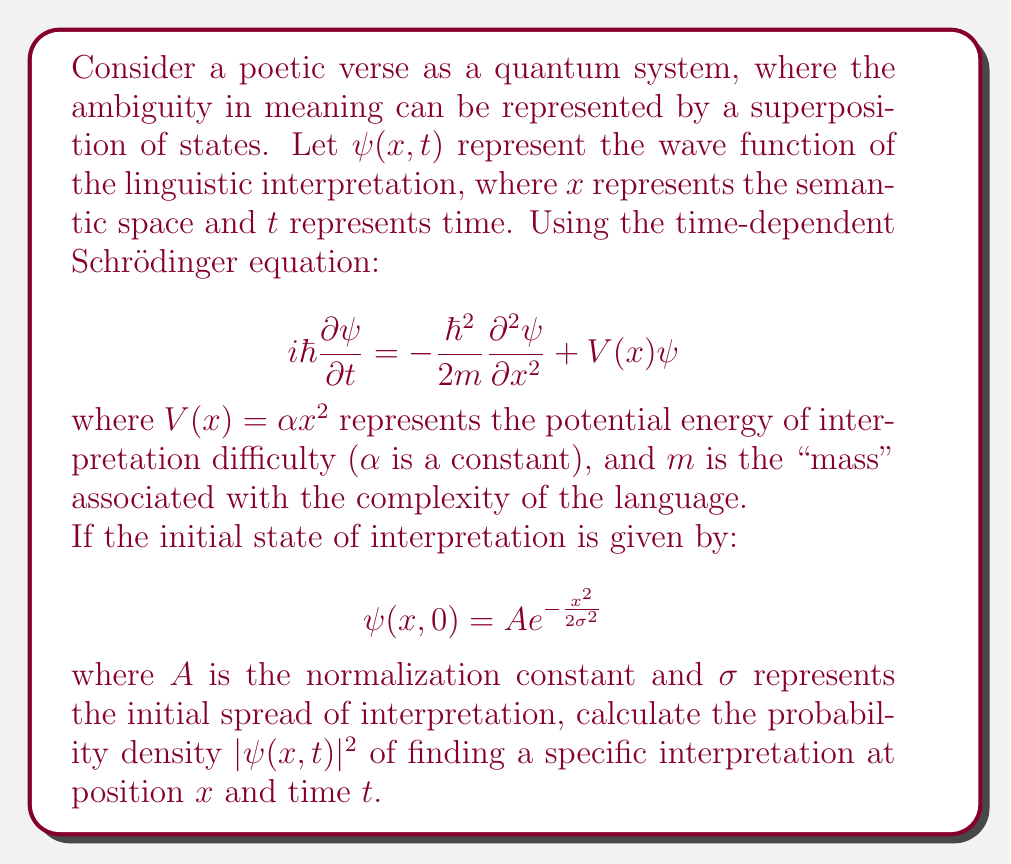Can you solve this math problem? To solve this problem, we need to follow these steps:

1) First, we need to find the solution to the time-dependent Schrödinger equation for the given potential $V(x) = \alpha x^2$. This is known as the quantum harmonic oscillator problem.

2) The general solution for the quantum harmonic oscillator is:

   $$\psi(x,t) = \left(\frac{m\omega}{\pi\hbar}\right)^{1/4} \exp\left(-\frac{m\omega x^2}{2\hbar}\right) \exp\left(-i\omega t/2\right)$$

   where $\omega = \sqrt{\frac{\alpha}{m}}$

3) However, our initial condition is different. We need to use the method of propagators to find the specific solution for our initial condition.

4) The propagator for the harmonic oscillator is:

   $$K(x,x',t) = \sqrt{\frac{m\omega}{2\pi i\hbar \sin(\omega t)}} \exp\left[\frac{im\omega}{2\hbar\sin(\omega t)}((x^2+x'^2)\cos(\omega t)-2xx')\right]$$

5) The solution at time $t$ is given by:

   $$\psi(x,t) = \int_{-\infty}^{\infty} K(x,x',t)\psi(x',0)dx'$$

6) Substituting our initial condition and the propagator, and performing the integration (which involves complex Gaussian integrals), we get:

   $$\psi(x,t) = A\sqrt{\frac{\sigma^2}{\sigma^2\cos^2(\omega t)+\frac{\hbar^2}{4m^2\omega^2\sigma^2}\sin^2(\omega t)}} \exp\left(-\frac{x^2}{2(\sigma^2\cos^2(\omega t)+\frac{\hbar^2}{4m^2\omega^2\sigma^2}\sin^2(\omega t))}\right) \exp\left(i\phi(t)\right)$$

   where $\phi(t)$ is a phase factor that doesn't affect the probability density.

7) The probability density is given by $|\psi(x,t)|^2$, which is:

   $$|\psi(x,t)|^2 = |A|^2\frac{\sigma^2}{\sigma^2\cos^2(\omega t)+\frac{\hbar^2}{4m^2\omega^2\sigma^2}\sin^2(\omega t)} \exp\left(-\frac{x^2}{\sigma^2\cos^2(\omega t)+\frac{\hbar^2}{4m^2\omega^2\sigma^2}\sin^2(\omega t)}\right)$$

This expression represents the probability density of finding a specific interpretation at position $x$ and time $t$ in the semantic space.
Answer: The probability density of finding a specific interpretation at position $x$ and time $t$ is:

$$|\psi(x,t)|^2 = |A|^2\frac{\sigma^2}{\sigma^2\cos^2(\omega t)+\frac{\hbar^2}{4m^2\omega^2\sigma^2}\sin^2(\omega t)} \exp\left(-\frac{x^2}{\sigma^2\cos^2(\omega t)+\frac{\hbar^2}{4m^2\omega^2\sigma^2}\sin^2(\omega t)}\right)$$

where $\omega = \sqrt{\frac{\alpha}{m}}$, $\alpha$ is the constant in the potential energy function, $m$ is the "mass" associated with language complexity, $\sigma$ is the initial spread of interpretation, and $A$ is the normalization constant. 